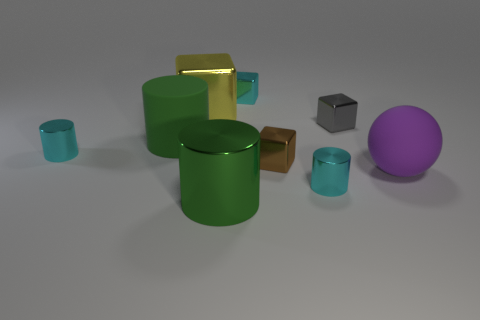Describe the sizes of the objects. Which is the largest and which is the smallest? Within the image, the largest object is the large green cylinder, while the smallest objects are the two small gray cubes. 